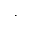Convert formula to latex. <formula><loc_0><loc_0><loc_500><loc_500>\cdot</formula> 